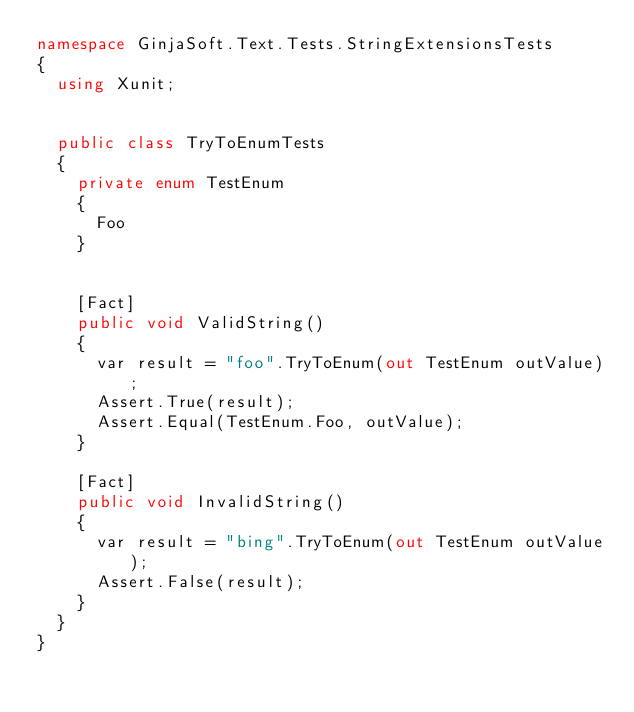<code> <loc_0><loc_0><loc_500><loc_500><_C#_>namespace GinjaSoft.Text.Tests.StringExtensionsTests
{
  using Xunit;


  public class TryToEnumTests
  {
    private enum TestEnum
    {
      Foo
    }


    [Fact]
    public void ValidString()
    {
      var result = "foo".TryToEnum(out TestEnum outValue);
      Assert.True(result);
      Assert.Equal(TestEnum.Foo, outValue);
    }

    [Fact]
    public void InvalidString()
    {
      var result = "bing".TryToEnum(out TestEnum outValue);
      Assert.False(result);
    }
  }
}
</code> 